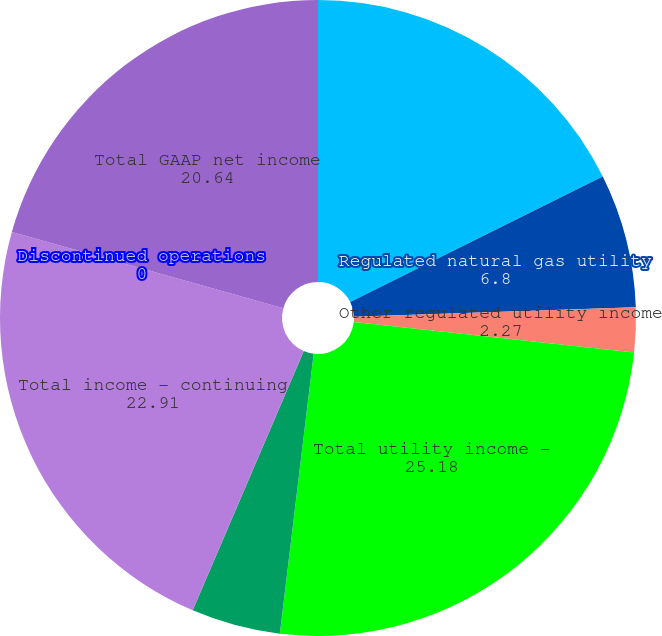Convert chart. <chart><loc_0><loc_0><loc_500><loc_500><pie_chart><fcel>Regulated electric utility<fcel>Regulated natural gas utility<fcel>Other regulated utility income<fcel>Total utility income -<fcel>Holding company costs and<fcel>Total income - continuing<fcel>Discontinued operations<fcel>Total GAAP net income<nl><fcel>17.66%<fcel>6.8%<fcel>2.27%<fcel>25.18%<fcel>4.53%<fcel>22.91%<fcel>0.0%<fcel>20.64%<nl></chart> 